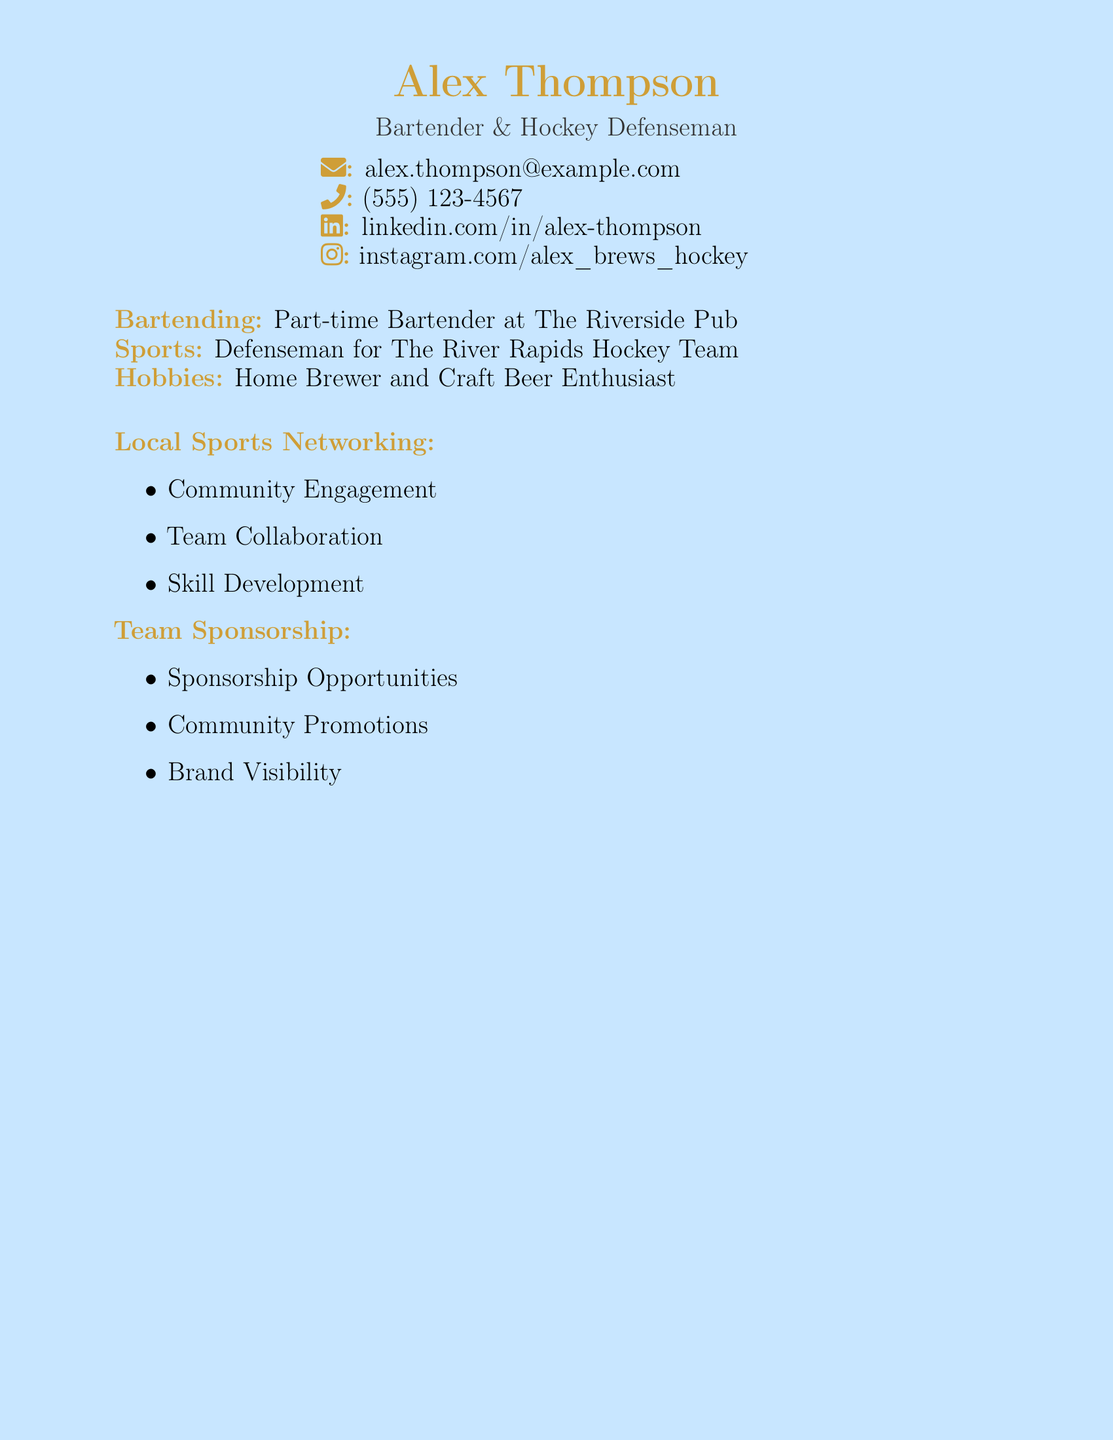What is the name of the person on the card? The name "Alex Thompson" is prominently displayed at the top of the document.
Answer: Alex Thompson What is the email address provided? The email address is listed next to the envelope icon in the contact information section.
Answer: alex.thompson@example.com What is Alex's role in the hockey team? The document states that Alex is a "Defenseman" for his hockey team.
Answer: Defenseman What is one of Alex's hobbies? One of Alex's hobbies is stated under the hobbies section as "Home Brewer and Craft Beer Enthusiast."
Answer: Home Brewer What is mentioned under Local Sports Networking? The section lists three points including "Community Engagement," "Team Collaboration," and "Skill Development."
Answer: Community Engagement What is one key aspect of Team Sponsorship? The section includes multiple points, with one being "Sponsorship Opportunities."
Answer: Sponsorship Opportunities How many phone numbers are listed on the card? The card provides a single phone number next to the phone icon as part of the contact section.
Answer: One What is the title indicated under Alex's name? The title provided under Alex's name indicates his roles as a Bartender and Hockey Defenseman.
Answer: Bartender & Hockey Defenseman What type of document is this? The format and layout suggest this is a business card for personal branding and networking purposes.
Answer: Business Card 